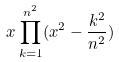<formula> <loc_0><loc_0><loc_500><loc_500>x \prod _ { k = 1 } ^ { n ^ { 2 } } ( x ^ { 2 } - \frac { k ^ { 2 } } { n ^ { 2 } } )</formula> 